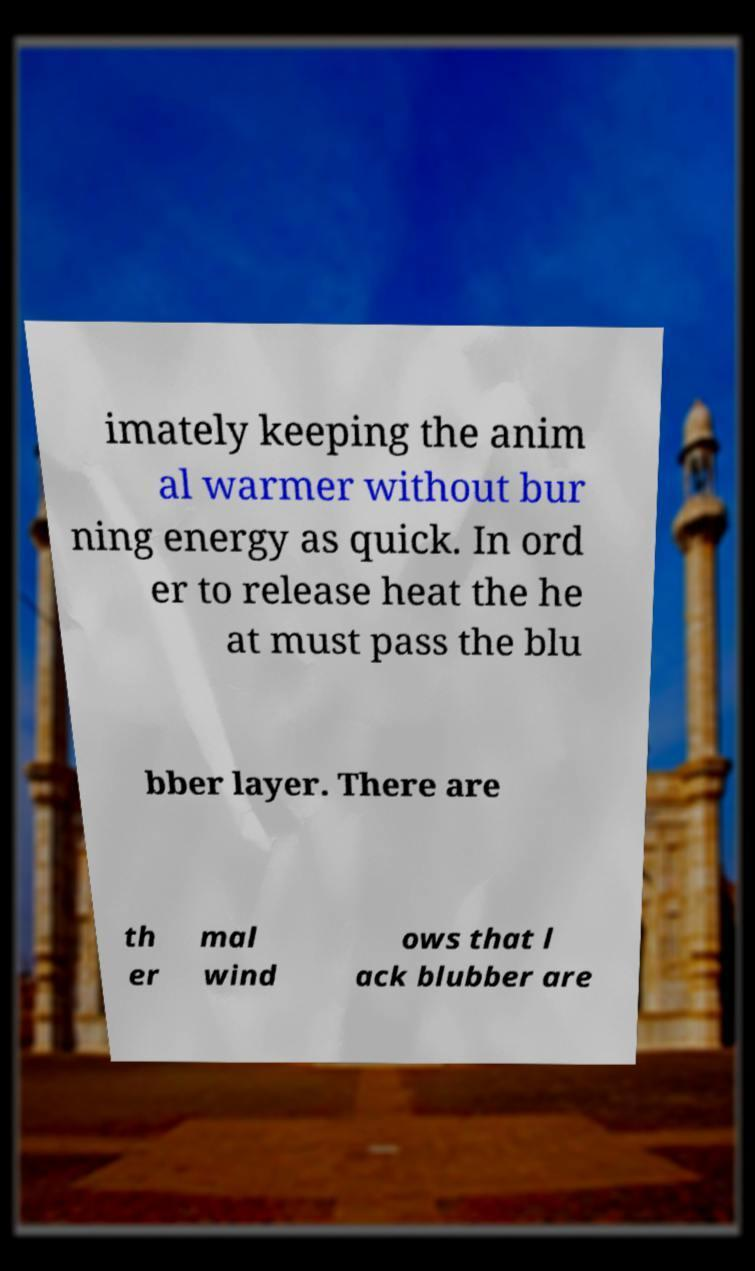I need the written content from this picture converted into text. Can you do that? imately keeping the anim al warmer without bur ning energy as quick. In ord er to release heat the he at must pass the blu bber layer. There are th er mal wind ows that l ack blubber are 